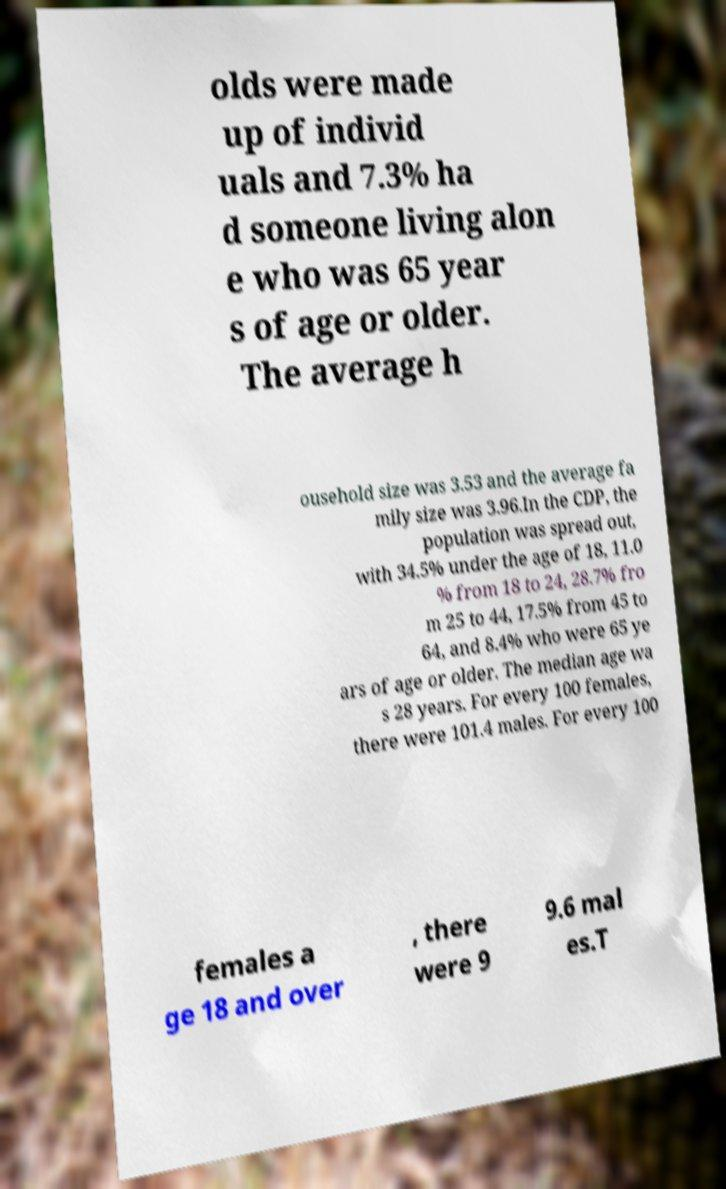For documentation purposes, I need the text within this image transcribed. Could you provide that? olds were made up of individ uals and 7.3% ha d someone living alon e who was 65 year s of age or older. The average h ousehold size was 3.53 and the average fa mily size was 3.96.In the CDP, the population was spread out, with 34.5% under the age of 18, 11.0 % from 18 to 24, 28.7% fro m 25 to 44, 17.5% from 45 to 64, and 8.4% who were 65 ye ars of age or older. The median age wa s 28 years. For every 100 females, there were 101.4 males. For every 100 females a ge 18 and over , there were 9 9.6 mal es.T 